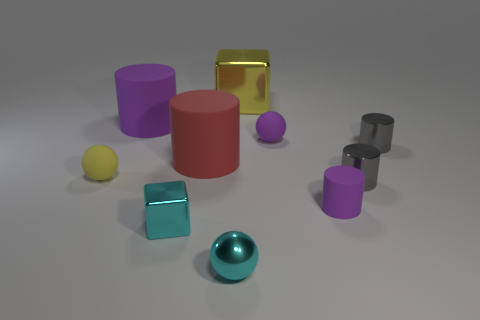How many other things are the same color as the tiny cube?
Your answer should be very brief. 1. Do the tiny purple cylinder in front of the big red cylinder and the small purple sphere have the same material?
Your response must be concise. Yes. Are there fewer small metal balls that are left of the big red rubber thing than yellow matte things to the left of the big yellow block?
Make the answer very short. Yes. How many other objects are there of the same material as the big yellow object?
Provide a short and direct response. 4. There is a yellow block that is the same size as the red cylinder; what is its material?
Give a very brief answer. Metal. Is the number of tiny shiny cylinders that are in front of the small cyan cube less than the number of brown rubber balls?
Keep it short and to the point. No. What is the shape of the tiny purple thing that is behind the purple cylinder right of the tiny rubber ball that is behind the small yellow matte sphere?
Make the answer very short. Sphere. What size is the purple cylinder that is right of the large cube?
Provide a succinct answer. Small. The red matte thing that is the same size as the yellow metal block is what shape?
Ensure brevity in your answer.  Cylinder. What number of objects are tiny gray shiny spheres or purple cylinders to the right of the large metallic block?
Make the answer very short. 1. 